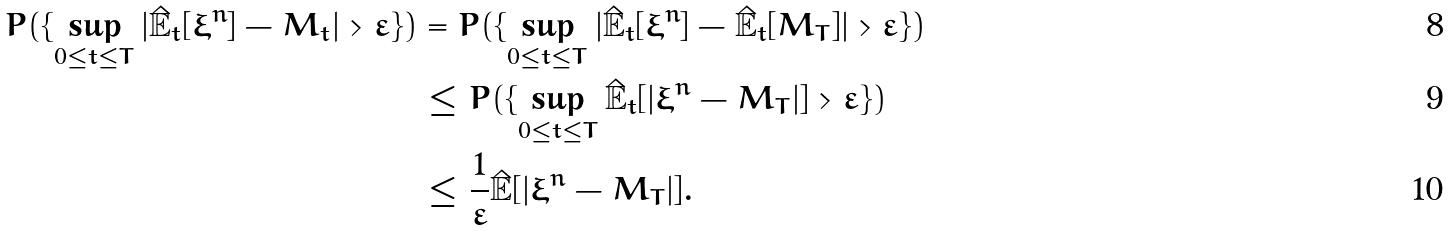Convert formula to latex. <formula><loc_0><loc_0><loc_500><loc_500>P ( \{ \sup _ { 0 \leq t \leq T } | \mathbb { \hat { E } } _ { t } [ \xi ^ { n } ] - M _ { t } | > \varepsilon \} ) & = P ( \{ \sup _ { 0 \leq t \leq T } | \mathbb { \hat { E } } _ { t } [ \xi ^ { n } ] - \mathbb { \hat { E } } _ { t } [ M _ { T } ] | > \varepsilon \} ) \\ & \leq P ( \{ \sup _ { 0 \leq t \leq T } \mathbb { \hat { E } } _ { t } [ | \xi ^ { n } - M _ { T } | ] > \varepsilon \} ) \\ & \leq \frac { 1 } { \varepsilon } \mathbb { \hat { E } } [ | \xi ^ { n } - M _ { T } | ] .</formula> 